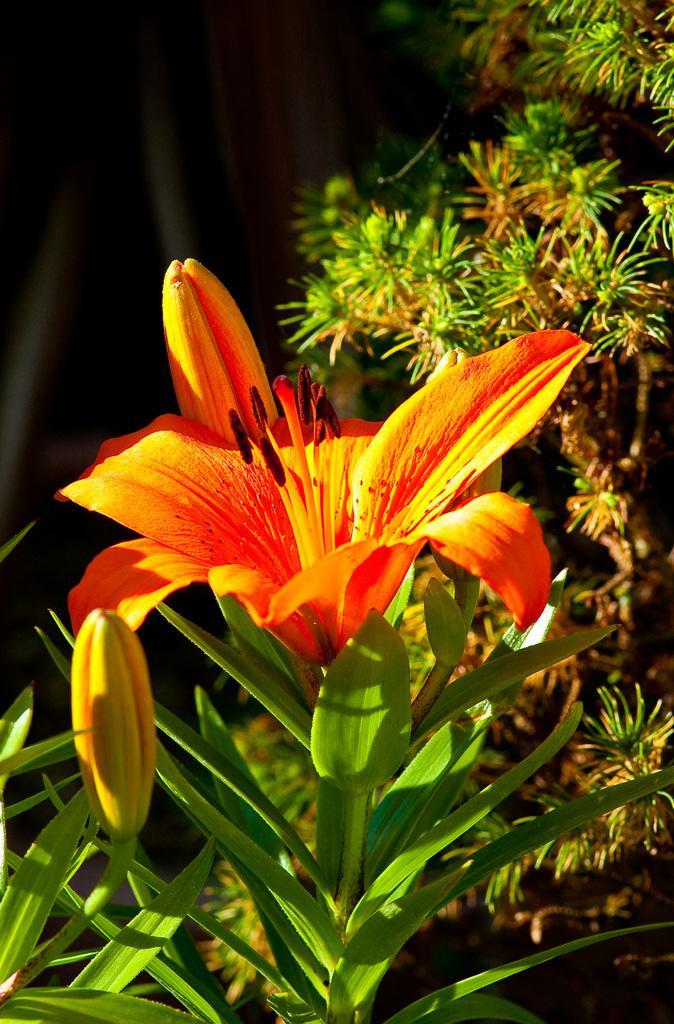Please provide a concise description of this image. In the image we can see there is a flower and there are buds on the plant. Behind there are other plants and background of the image is dark. 